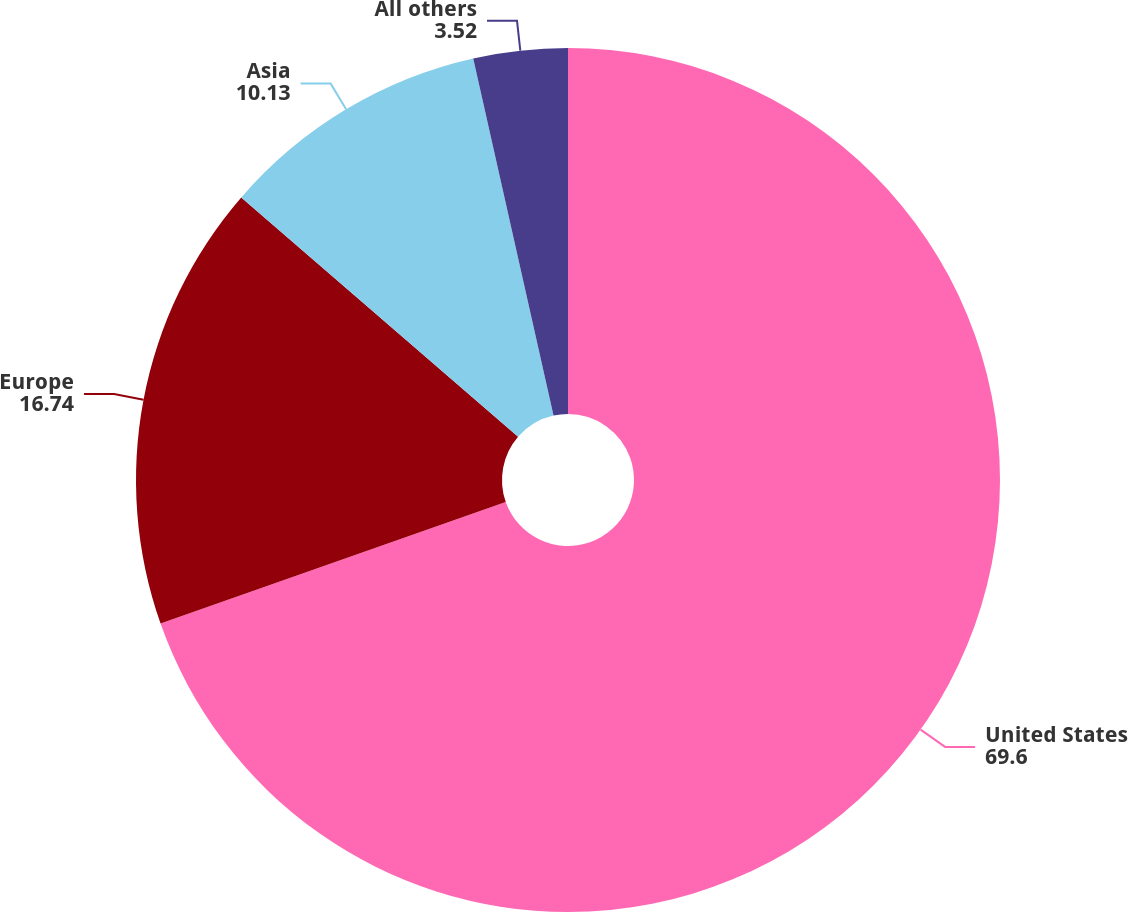Convert chart to OTSL. <chart><loc_0><loc_0><loc_500><loc_500><pie_chart><fcel>United States<fcel>Europe<fcel>Asia<fcel>All others<nl><fcel>69.6%<fcel>16.74%<fcel>10.13%<fcel>3.52%<nl></chart> 